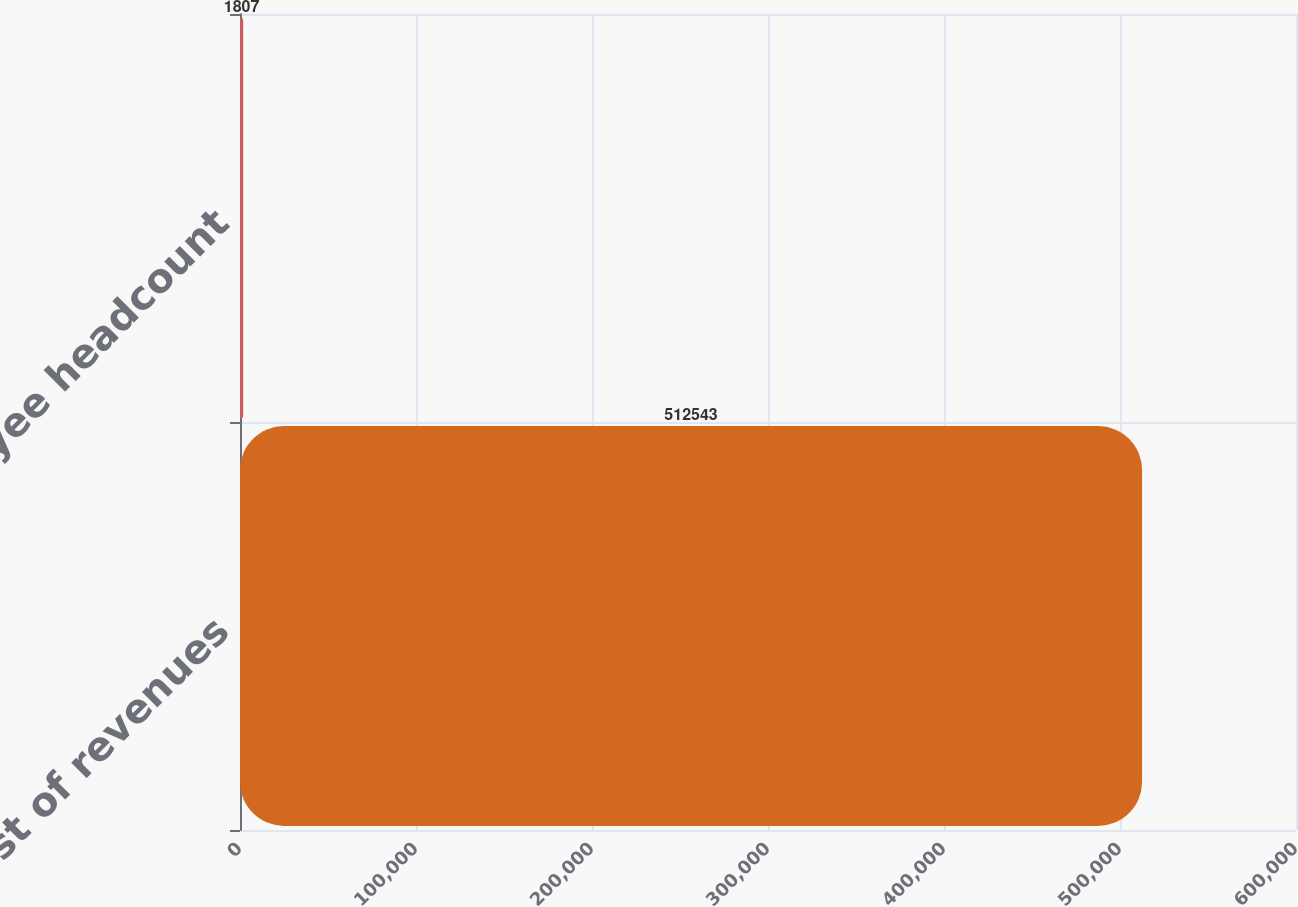Convert chart. <chart><loc_0><loc_0><loc_500><loc_500><bar_chart><fcel>Cost of revenues<fcel>Employee headcount<nl><fcel>512543<fcel>1807<nl></chart> 